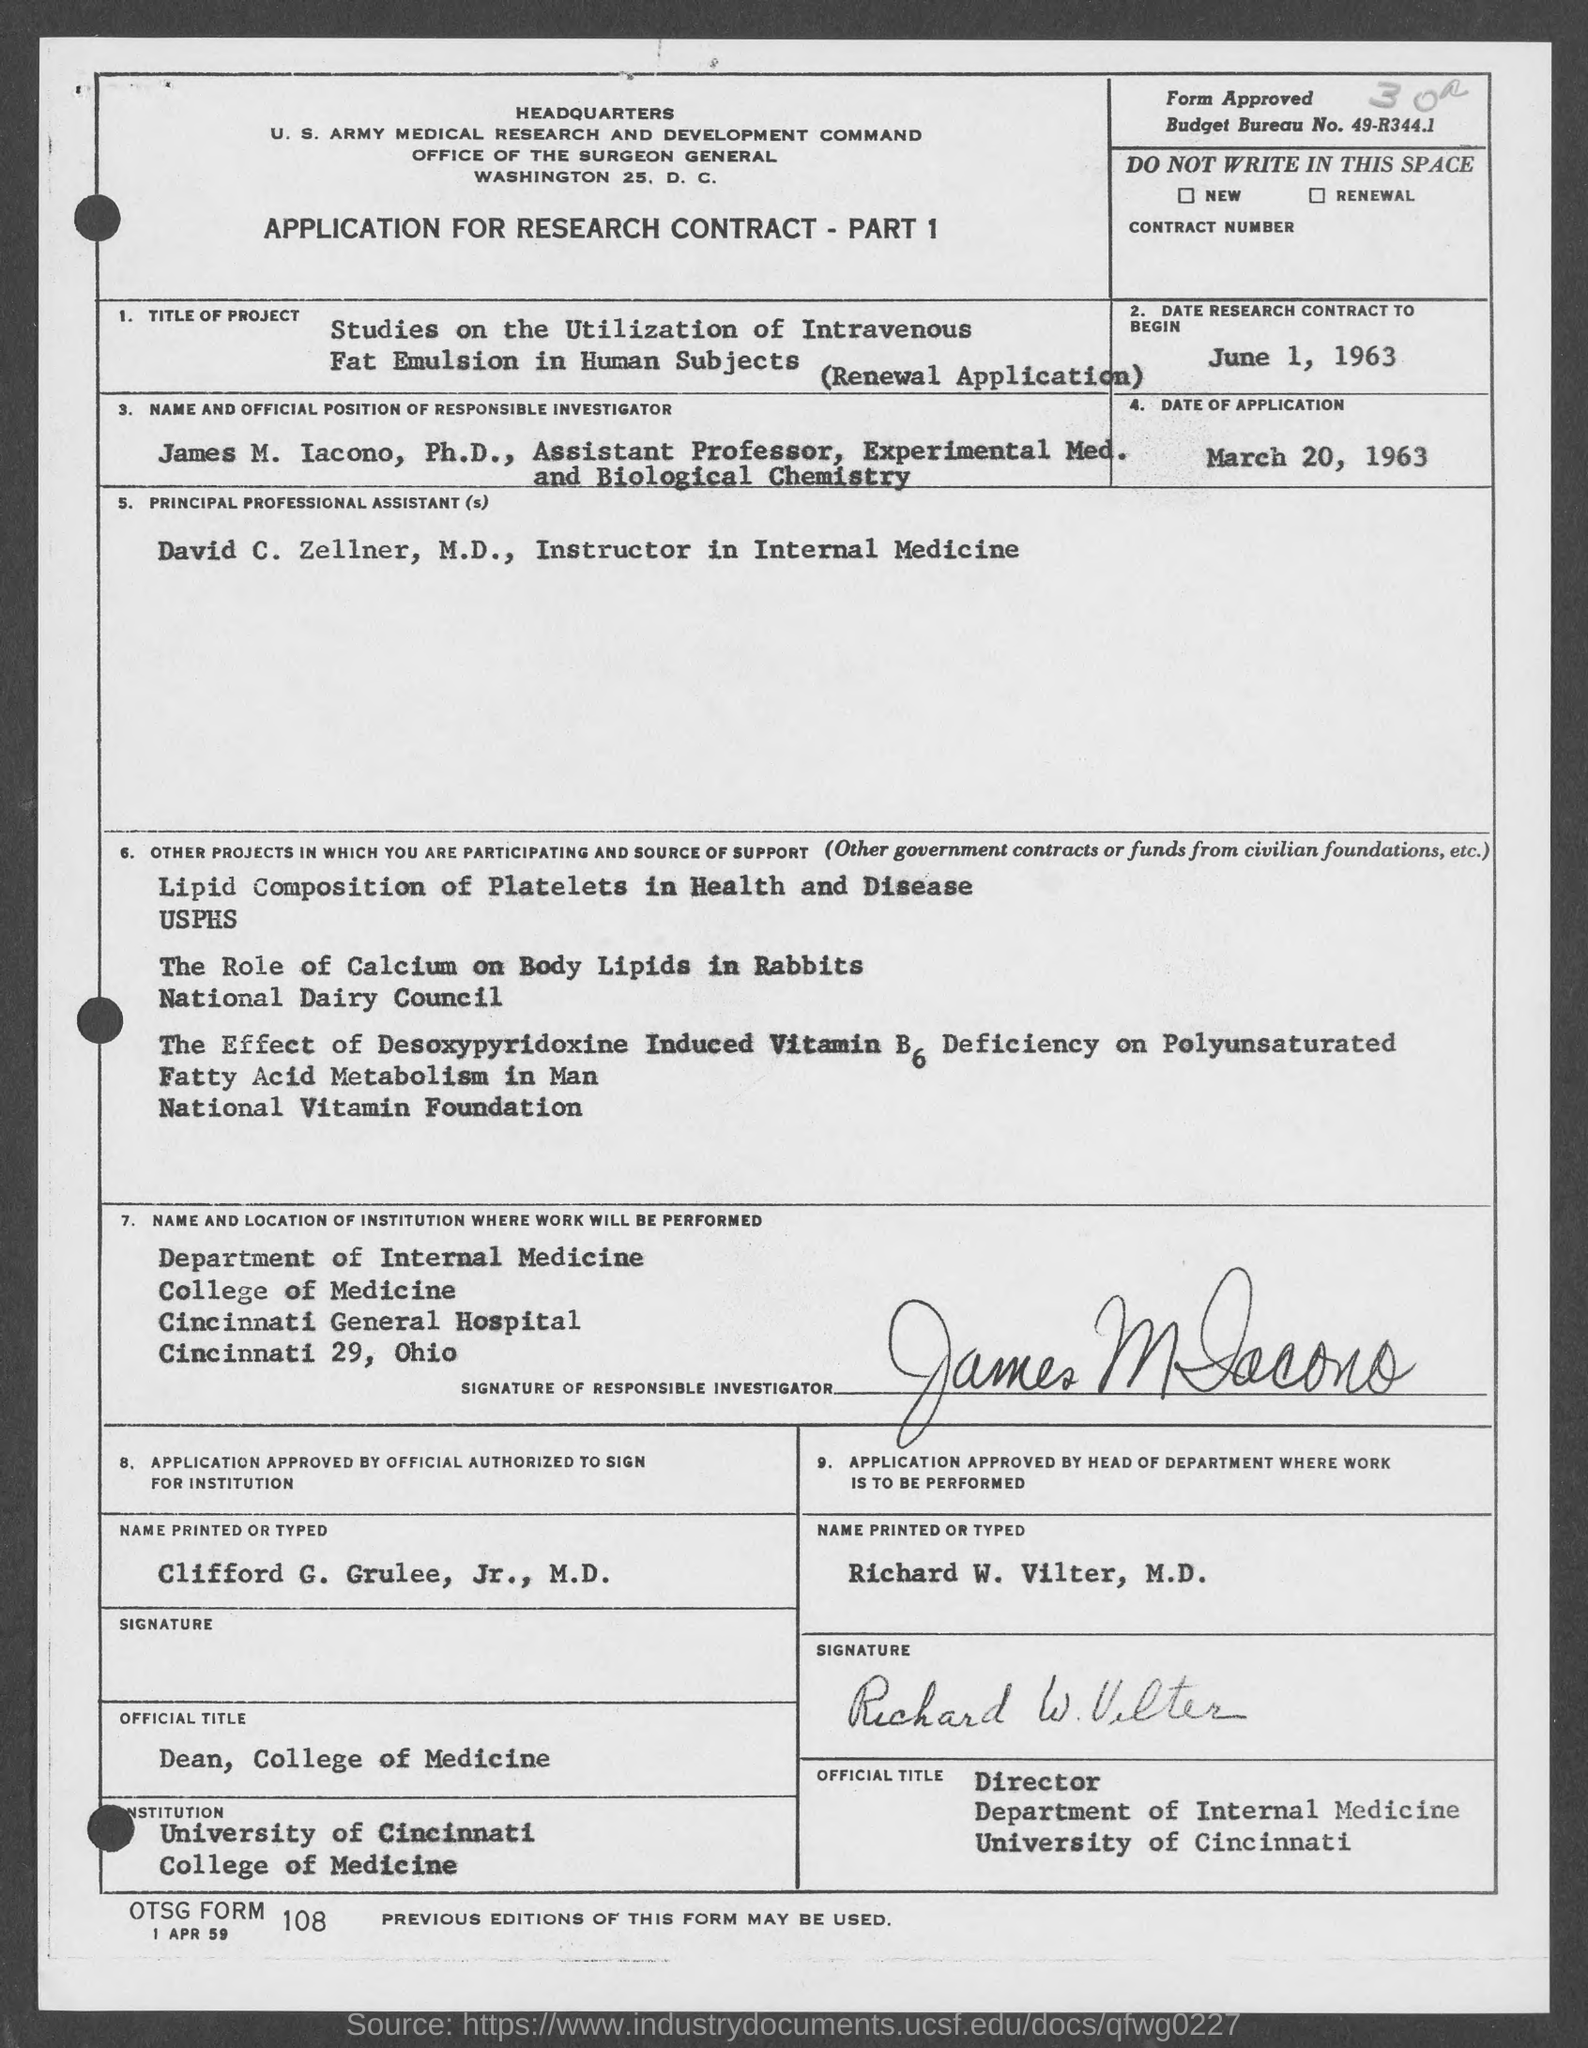What is the date of application mentioned in the given form ?
Provide a short and direct response. March 20, 1963. What is the date given for research contract to begin as mentioned in the given form ?
Make the answer very short. June 1, 1963. What is the budget bureau no. mentioned in the given form ?
Make the answer very short. Budget bureau no. 49-r344.1. 